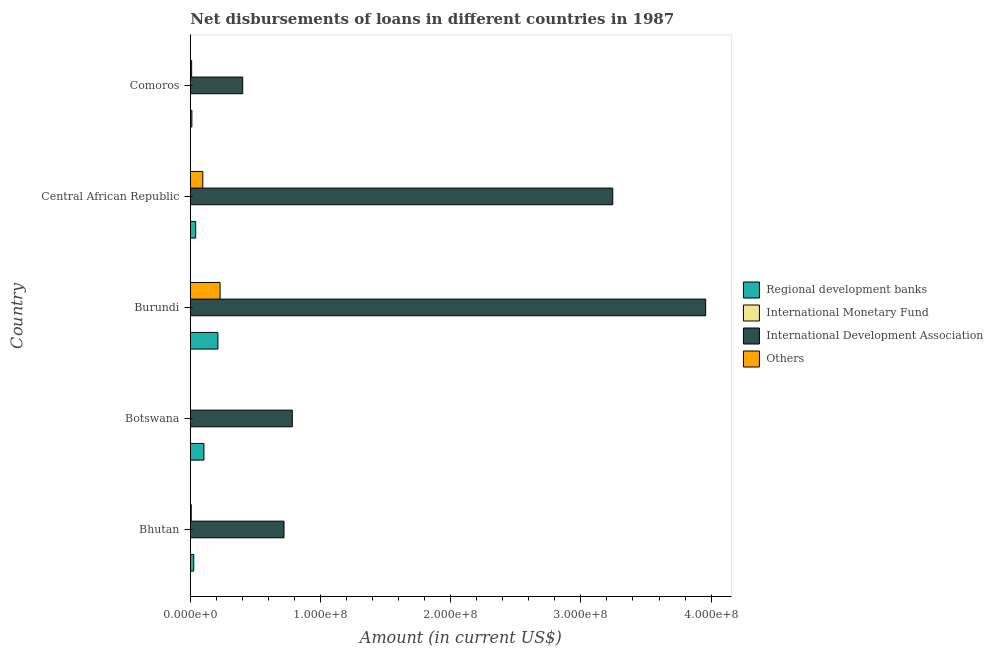How many different coloured bars are there?
Keep it short and to the point. 3. What is the label of the 2nd group of bars from the top?
Make the answer very short. Central African Republic. In how many cases, is the number of bars for a given country not equal to the number of legend labels?
Make the answer very short. 5. What is the amount of loan disimbursed by other organisations in Comoros?
Your answer should be compact. 1.03e+06. Across all countries, what is the maximum amount of loan disimbursed by regional development banks?
Provide a succinct answer. 2.12e+07. Across all countries, what is the minimum amount of loan disimbursed by international development association?
Ensure brevity in your answer.  4.03e+07. In which country was the amount of loan disimbursed by international development association maximum?
Your answer should be compact. Burundi. What is the difference between the amount of loan disimbursed by regional development banks in Botswana and that in Central African Republic?
Your response must be concise. 6.32e+06. What is the difference between the amount of loan disimbursed by other organisations in Botswana and the amount of loan disimbursed by regional development banks in Central African Republic?
Ensure brevity in your answer.  -4.15e+06. What is the average amount of loan disimbursed by other organisations per country?
Offer a terse response. 6.84e+06. What is the difference between the amount of loan disimbursed by other organisations and amount of loan disimbursed by international development association in Bhutan?
Give a very brief answer. -7.12e+07. In how many countries, is the amount of loan disimbursed by international development association greater than 300000000 US$?
Give a very brief answer. 2. What is the ratio of the amount of loan disimbursed by regional development banks in Botswana to that in Burundi?
Offer a very short reply. 0.49. What is the difference between the highest and the second highest amount of loan disimbursed by other organisations?
Make the answer very short. 1.33e+07. What is the difference between the highest and the lowest amount of loan disimbursed by regional development banks?
Your response must be concise. 2.00e+07. In how many countries, is the amount of loan disimbursed by regional development banks greater than the average amount of loan disimbursed by regional development banks taken over all countries?
Your answer should be very brief. 2. Is it the case that in every country, the sum of the amount of loan disimbursed by international development association and amount of loan disimbursed by other organisations is greater than the sum of amount of loan disimbursed by regional development banks and amount of loan disimbursed by international monetary fund?
Give a very brief answer. Yes. Is it the case that in every country, the sum of the amount of loan disimbursed by regional development banks and amount of loan disimbursed by international monetary fund is greater than the amount of loan disimbursed by international development association?
Your answer should be very brief. No. Are all the bars in the graph horizontal?
Your answer should be compact. Yes. Are the values on the major ticks of X-axis written in scientific E-notation?
Keep it short and to the point. Yes. Does the graph contain grids?
Your answer should be very brief. No. What is the title of the graph?
Keep it short and to the point. Net disbursements of loans in different countries in 1987. What is the Amount (in current US$) in Regional development banks in Bhutan?
Provide a succinct answer. 2.67e+06. What is the Amount (in current US$) in International Development Association in Bhutan?
Your answer should be compact. 7.20e+07. What is the Amount (in current US$) of Others in Bhutan?
Provide a succinct answer. 7.32e+05. What is the Amount (in current US$) of Regional development banks in Botswana?
Provide a short and direct response. 1.05e+07. What is the Amount (in current US$) of International Development Association in Botswana?
Your answer should be compact. 7.84e+07. What is the Amount (in current US$) of Others in Botswana?
Make the answer very short. 0. What is the Amount (in current US$) of Regional development banks in Burundi?
Provide a short and direct response. 2.12e+07. What is the Amount (in current US$) in International Monetary Fund in Burundi?
Give a very brief answer. 0. What is the Amount (in current US$) of International Development Association in Burundi?
Offer a very short reply. 3.96e+08. What is the Amount (in current US$) in Others in Burundi?
Provide a short and direct response. 2.29e+07. What is the Amount (in current US$) in Regional development banks in Central African Republic?
Your answer should be very brief. 4.15e+06. What is the Amount (in current US$) in International Monetary Fund in Central African Republic?
Offer a very short reply. 0. What is the Amount (in current US$) in International Development Association in Central African Republic?
Ensure brevity in your answer.  3.24e+08. What is the Amount (in current US$) in Others in Central African Republic?
Your answer should be very brief. 9.60e+06. What is the Amount (in current US$) in Regional development banks in Comoros?
Make the answer very short. 1.21e+06. What is the Amount (in current US$) in International Monetary Fund in Comoros?
Offer a very short reply. 0. What is the Amount (in current US$) of International Development Association in Comoros?
Ensure brevity in your answer.  4.03e+07. What is the Amount (in current US$) in Others in Comoros?
Keep it short and to the point. 1.03e+06. Across all countries, what is the maximum Amount (in current US$) in Regional development banks?
Offer a very short reply. 2.12e+07. Across all countries, what is the maximum Amount (in current US$) in International Development Association?
Offer a very short reply. 3.96e+08. Across all countries, what is the maximum Amount (in current US$) of Others?
Offer a very short reply. 2.29e+07. Across all countries, what is the minimum Amount (in current US$) in Regional development banks?
Your answer should be very brief. 1.21e+06. Across all countries, what is the minimum Amount (in current US$) of International Development Association?
Provide a short and direct response. 4.03e+07. What is the total Amount (in current US$) of Regional development banks in the graph?
Ensure brevity in your answer.  3.97e+07. What is the total Amount (in current US$) of International Development Association in the graph?
Ensure brevity in your answer.  9.11e+08. What is the total Amount (in current US$) in Others in the graph?
Ensure brevity in your answer.  3.42e+07. What is the difference between the Amount (in current US$) in Regional development banks in Bhutan and that in Botswana?
Your response must be concise. -7.80e+06. What is the difference between the Amount (in current US$) in International Development Association in Bhutan and that in Botswana?
Provide a succinct answer. -6.38e+06. What is the difference between the Amount (in current US$) in Regional development banks in Bhutan and that in Burundi?
Provide a short and direct response. -1.85e+07. What is the difference between the Amount (in current US$) in International Development Association in Bhutan and that in Burundi?
Keep it short and to the point. -3.24e+08. What is the difference between the Amount (in current US$) in Others in Bhutan and that in Burundi?
Keep it short and to the point. -2.21e+07. What is the difference between the Amount (in current US$) of Regional development banks in Bhutan and that in Central African Republic?
Provide a succinct answer. -1.48e+06. What is the difference between the Amount (in current US$) of International Development Association in Bhutan and that in Central African Republic?
Ensure brevity in your answer.  -2.53e+08. What is the difference between the Amount (in current US$) of Others in Bhutan and that in Central African Republic?
Provide a succinct answer. -8.86e+06. What is the difference between the Amount (in current US$) in Regional development banks in Bhutan and that in Comoros?
Provide a succinct answer. 1.45e+06. What is the difference between the Amount (in current US$) in International Development Association in Bhutan and that in Comoros?
Make the answer very short. 3.17e+07. What is the difference between the Amount (in current US$) of Others in Bhutan and that in Comoros?
Keep it short and to the point. -2.98e+05. What is the difference between the Amount (in current US$) of Regional development banks in Botswana and that in Burundi?
Provide a short and direct response. -1.07e+07. What is the difference between the Amount (in current US$) in International Development Association in Botswana and that in Burundi?
Ensure brevity in your answer.  -3.17e+08. What is the difference between the Amount (in current US$) of Regional development banks in Botswana and that in Central African Republic?
Your answer should be very brief. 6.32e+06. What is the difference between the Amount (in current US$) in International Development Association in Botswana and that in Central African Republic?
Provide a short and direct response. -2.46e+08. What is the difference between the Amount (in current US$) of Regional development banks in Botswana and that in Comoros?
Your answer should be very brief. 9.26e+06. What is the difference between the Amount (in current US$) of International Development Association in Botswana and that in Comoros?
Offer a terse response. 3.81e+07. What is the difference between the Amount (in current US$) of Regional development banks in Burundi and that in Central African Republic?
Keep it short and to the point. 1.71e+07. What is the difference between the Amount (in current US$) in International Development Association in Burundi and that in Central African Republic?
Your answer should be very brief. 7.13e+07. What is the difference between the Amount (in current US$) in Others in Burundi and that in Central African Republic?
Make the answer very short. 1.33e+07. What is the difference between the Amount (in current US$) in Regional development banks in Burundi and that in Comoros?
Ensure brevity in your answer.  2.00e+07. What is the difference between the Amount (in current US$) in International Development Association in Burundi and that in Comoros?
Keep it short and to the point. 3.56e+08. What is the difference between the Amount (in current US$) of Others in Burundi and that in Comoros?
Offer a very short reply. 2.18e+07. What is the difference between the Amount (in current US$) in Regional development banks in Central African Republic and that in Comoros?
Your answer should be compact. 2.93e+06. What is the difference between the Amount (in current US$) in International Development Association in Central African Republic and that in Comoros?
Your answer should be very brief. 2.84e+08. What is the difference between the Amount (in current US$) of Others in Central African Republic and that in Comoros?
Give a very brief answer. 8.56e+06. What is the difference between the Amount (in current US$) in Regional development banks in Bhutan and the Amount (in current US$) in International Development Association in Botswana?
Provide a succinct answer. -7.57e+07. What is the difference between the Amount (in current US$) of Regional development banks in Bhutan and the Amount (in current US$) of International Development Association in Burundi?
Ensure brevity in your answer.  -3.93e+08. What is the difference between the Amount (in current US$) in Regional development banks in Bhutan and the Amount (in current US$) in Others in Burundi?
Offer a very short reply. -2.02e+07. What is the difference between the Amount (in current US$) in International Development Association in Bhutan and the Amount (in current US$) in Others in Burundi?
Give a very brief answer. 4.91e+07. What is the difference between the Amount (in current US$) in Regional development banks in Bhutan and the Amount (in current US$) in International Development Association in Central African Republic?
Make the answer very short. -3.22e+08. What is the difference between the Amount (in current US$) in Regional development banks in Bhutan and the Amount (in current US$) in Others in Central African Republic?
Keep it short and to the point. -6.93e+06. What is the difference between the Amount (in current US$) in International Development Association in Bhutan and the Amount (in current US$) in Others in Central African Republic?
Give a very brief answer. 6.24e+07. What is the difference between the Amount (in current US$) in Regional development banks in Bhutan and the Amount (in current US$) in International Development Association in Comoros?
Provide a short and direct response. -3.76e+07. What is the difference between the Amount (in current US$) of Regional development banks in Bhutan and the Amount (in current US$) of Others in Comoros?
Make the answer very short. 1.64e+06. What is the difference between the Amount (in current US$) of International Development Association in Bhutan and the Amount (in current US$) of Others in Comoros?
Make the answer very short. 7.09e+07. What is the difference between the Amount (in current US$) of Regional development banks in Botswana and the Amount (in current US$) of International Development Association in Burundi?
Your answer should be very brief. -3.85e+08. What is the difference between the Amount (in current US$) of Regional development banks in Botswana and the Amount (in current US$) of Others in Burundi?
Your answer should be compact. -1.24e+07. What is the difference between the Amount (in current US$) of International Development Association in Botswana and the Amount (in current US$) of Others in Burundi?
Keep it short and to the point. 5.55e+07. What is the difference between the Amount (in current US$) in Regional development banks in Botswana and the Amount (in current US$) in International Development Association in Central African Republic?
Your answer should be very brief. -3.14e+08. What is the difference between the Amount (in current US$) of Regional development banks in Botswana and the Amount (in current US$) of Others in Central African Republic?
Ensure brevity in your answer.  8.74e+05. What is the difference between the Amount (in current US$) of International Development Association in Botswana and the Amount (in current US$) of Others in Central African Republic?
Your answer should be very brief. 6.88e+07. What is the difference between the Amount (in current US$) in Regional development banks in Botswana and the Amount (in current US$) in International Development Association in Comoros?
Your response must be concise. -2.98e+07. What is the difference between the Amount (in current US$) of Regional development banks in Botswana and the Amount (in current US$) of Others in Comoros?
Ensure brevity in your answer.  9.44e+06. What is the difference between the Amount (in current US$) of International Development Association in Botswana and the Amount (in current US$) of Others in Comoros?
Ensure brevity in your answer.  7.73e+07. What is the difference between the Amount (in current US$) in Regional development banks in Burundi and the Amount (in current US$) in International Development Association in Central African Republic?
Keep it short and to the point. -3.03e+08. What is the difference between the Amount (in current US$) of Regional development banks in Burundi and the Amount (in current US$) of Others in Central African Republic?
Offer a very short reply. 1.16e+07. What is the difference between the Amount (in current US$) of International Development Association in Burundi and the Amount (in current US$) of Others in Central African Republic?
Give a very brief answer. 3.86e+08. What is the difference between the Amount (in current US$) of Regional development banks in Burundi and the Amount (in current US$) of International Development Association in Comoros?
Offer a terse response. -1.91e+07. What is the difference between the Amount (in current US$) of Regional development banks in Burundi and the Amount (in current US$) of Others in Comoros?
Keep it short and to the point. 2.02e+07. What is the difference between the Amount (in current US$) of International Development Association in Burundi and the Amount (in current US$) of Others in Comoros?
Provide a short and direct response. 3.95e+08. What is the difference between the Amount (in current US$) in Regional development banks in Central African Republic and the Amount (in current US$) in International Development Association in Comoros?
Ensure brevity in your answer.  -3.61e+07. What is the difference between the Amount (in current US$) in Regional development banks in Central African Republic and the Amount (in current US$) in Others in Comoros?
Your response must be concise. 3.12e+06. What is the difference between the Amount (in current US$) of International Development Association in Central African Republic and the Amount (in current US$) of Others in Comoros?
Ensure brevity in your answer.  3.23e+08. What is the average Amount (in current US$) in Regional development banks per country?
Ensure brevity in your answer.  7.94e+06. What is the average Amount (in current US$) in International Monetary Fund per country?
Offer a very short reply. 0. What is the average Amount (in current US$) of International Development Association per country?
Make the answer very short. 1.82e+08. What is the average Amount (in current US$) in Others per country?
Provide a short and direct response. 6.84e+06. What is the difference between the Amount (in current US$) in Regional development banks and Amount (in current US$) in International Development Association in Bhutan?
Your response must be concise. -6.93e+07. What is the difference between the Amount (in current US$) of Regional development banks and Amount (in current US$) of Others in Bhutan?
Give a very brief answer. 1.94e+06. What is the difference between the Amount (in current US$) in International Development Association and Amount (in current US$) in Others in Bhutan?
Keep it short and to the point. 7.12e+07. What is the difference between the Amount (in current US$) in Regional development banks and Amount (in current US$) in International Development Association in Botswana?
Make the answer very short. -6.79e+07. What is the difference between the Amount (in current US$) in Regional development banks and Amount (in current US$) in International Development Association in Burundi?
Provide a succinct answer. -3.75e+08. What is the difference between the Amount (in current US$) in Regional development banks and Amount (in current US$) in Others in Burundi?
Ensure brevity in your answer.  -1.66e+06. What is the difference between the Amount (in current US$) of International Development Association and Amount (in current US$) of Others in Burundi?
Your answer should be very brief. 3.73e+08. What is the difference between the Amount (in current US$) of Regional development banks and Amount (in current US$) of International Development Association in Central African Republic?
Make the answer very short. -3.20e+08. What is the difference between the Amount (in current US$) of Regional development banks and Amount (in current US$) of Others in Central African Republic?
Provide a succinct answer. -5.45e+06. What is the difference between the Amount (in current US$) of International Development Association and Amount (in current US$) of Others in Central African Republic?
Offer a terse response. 3.15e+08. What is the difference between the Amount (in current US$) of Regional development banks and Amount (in current US$) of International Development Association in Comoros?
Provide a short and direct response. -3.90e+07. What is the difference between the Amount (in current US$) of Regional development banks and Amount (in current US$) of Others in Comoros?
Provide a succinct answer. 1.84e+05. What is the difference between the Amount (in current US$) of International Development Association and Amount (in current US$) of Others in Comoros?
Keep it short and to the point. 3.92e+07. What is the ratio of the Amount (in current US$) of Regional development banks in Bhutan to that in Botswana?
Your answer should be compact. 0.25. What is the ratio of the Amount (in current US$) in International Development Association in Bhutan to that in Botswana?
Provide a short and direct response. 0.92. What is the ratio of the Amount (in current US$) in Regional development banks in Bhutan to that in Burundi?
Your answer should be very brief. 0.13. What is the ratio of the Amount (in current US$) in International Development Association in Bhutan to that in Burundi?
Your response must be concise. 0.18. What is the ratio of the Amount (in current US$) in Others in Bhutan to that in Burundi?
Give a very brief answer. 0.03. What is the ratio of the Amount (in current US$) in Regional development banks in Bhutan to that in Central African Republic?
Your answer should be very brief. 0.64. What is the ratio of the Amount (in current US$) in International Development Association in Bhutan to that in Central African Republic?
Your answer should be very brief. 0.22. What is the ratio of the Amount (in current US$) in Others in Bhutan to that in Central African Republic?
Offer a terse response. 0.08. What is the ratio of the Amount (in current US$) in Regional development banks in Bhutan to that in Comoros?
Make the answer very short. 2.2. What is the ratio of the Amount (in current US$) in International Development Association in Bhutan to that in Comoros?
Provide a short and direct response. 1.79. What is the ratio of the Amount (in current US$) of Others in Bhutan to that in Comoros?
Your answer should be very brief. 0.71. What is the ratio of the Amount (in current US$) in Regional development banks in Botswana to that in Burundi?
Offer a terse response. 0.49. What is the ratio of the Amount (in current US$) in International Development Association in Botswana to that in Burundi?
Your answer should be very brief. 0.2. What is the ratio of the Amount (in current US$) in Regional development banks in Botswana to that in Central African Republic?
Provide a short and direct response. 2.53. What is the ratio of the Amount (in current US$) of International Development Association in Botswana to that in Central African Republic?
Your response must be concise. 0.24. What is the ratio of the Amount (in current US$) of Regional development banks in Botswana to that in Comoros?
Provide a short and direct response. 8.62. What is the ratio of the Amount (in current US$) in International Development Association in Botswana to that in Comoros?
Keep it short and to the point. 1.95. What is the ratio of the Amount (in current US$) of Regional development banks in Burundi to that in Central African Republic?
Your response must be concise. 5.11. What is the ratio of the Amount (in current US$) in International Development Association in Burundi to that in Central African Republic?
Give a very brief answer. 1.22. What is the ratio of the Amount (in current US$) of Others in Burundi to that in Central African Republic?
Offer a very short reply. 2.38. What is the ratio of the Amount (in current US$) of Regional development banks in Burundi to that in Comoros?
Provide a short and direct response. 17.47. What is the ratio of the Amount (in current US$) of International Development Association in Burundi to that in Comoros?
Your answer should be compact. 9.83. What is the ratio of the Amount (in current US$) in Others in Burundi to that in Comoros?
Offer a terse response. 22.2. What is the ratio of the Amount (in current US$) in Regional development banks in Central African Republic to that in Comoros?
Make the answer very short. 3.42. What is the ratio of the Amount (in current US$) of International Development Association in Central African Republic to that in Comoros?
Your answer should be very brief. 8.06. What is the ratio of the Amount (in current US$) in Others in Central African Republic to that in Comoros?
Your answer should be very brief. 9.32. What is the difference between the highest and the second highest Amount (in current US$) of Regional development banks?
Provide a short and direct response. 1.07e+07. What is the difference between the highest and the second highest Amount (in current US$) in International Development Association?
Your answer should be compact. 7.13e+07. What is the difference between the highest and the second highest Amount (in current US$) in Others?
Your response must be concise. 1.33e+07. What is the difference between the highest and the lowest Amount (in current US$) of Regional development banks?
Keep it short and to the point. 2.00e+07. What is the difference between the highest and the lowest Amount (in current US$) of International Development Association?
Keep it short and to the point. 3.56e+08. What is the difference between the highest and the lowest Amount (in current US$) of Others?
Give a very brief answer. 2.29e+07. 